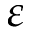Convert formula to latex. <formula><loc_0><loc_0><loc_500><loc_500>\varepsilon</formula> 